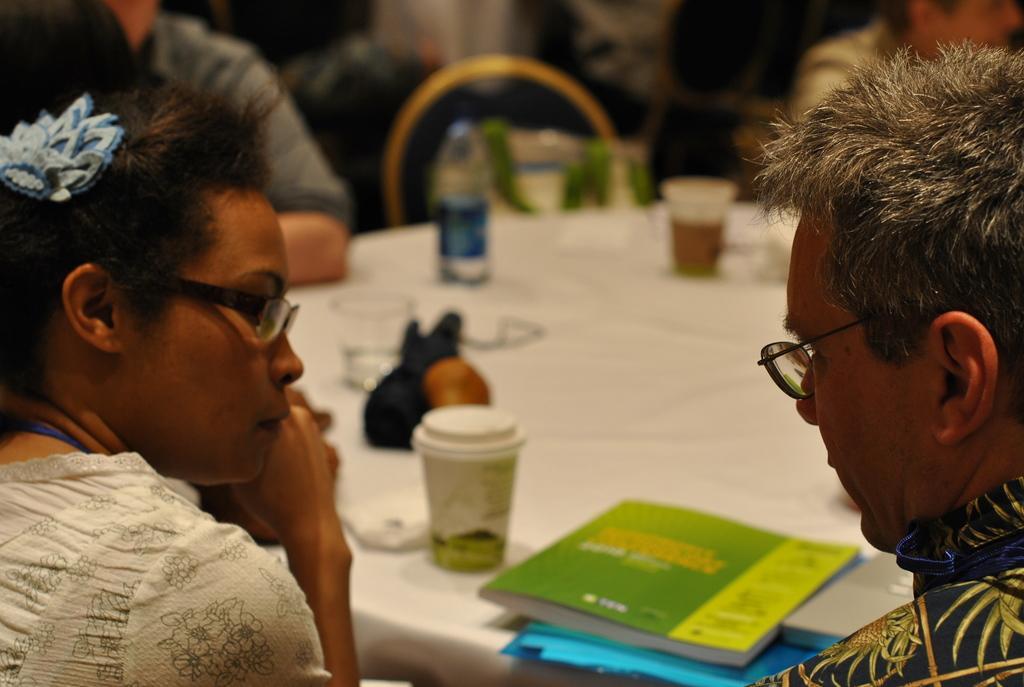In one or two sentences, can you explain what this image depicts? This image is taken indoors. At the bottom of the image there is a table with a tablecloth and a few things on it. On the left side of the image a woman and a man are sitting on the chairs. On the right side of the image a man is sitting on the chair. In the background there is an empty chair and there is a person. 